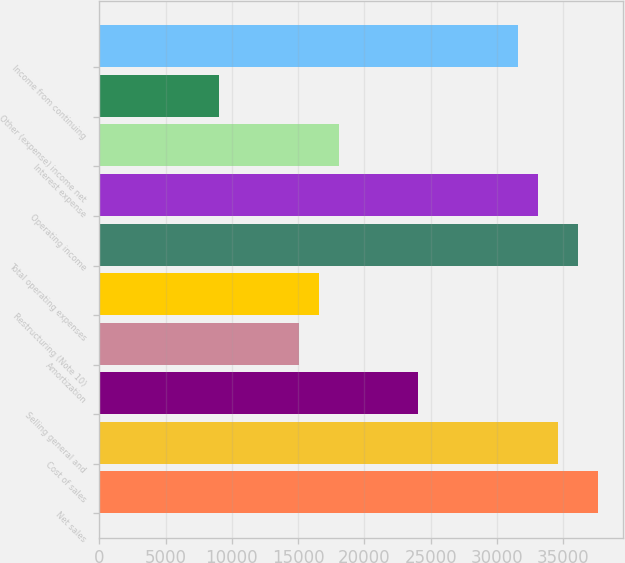Convert chart to OTSL. <chart><loc_0><loc_0><loc_500><loc_500><bar_chart><fcel>Net sales<fcel>Cost of sales<fcel>Selling general and<fcel>Amortization<fcel>Restructuring (Note 10)<fcel>Total operating expenses<fcel>Operating income<fcel>Interest expense<fcel>Other (expense) income net<fcel>Income from continuing<nl><fcel>37627.4<fcel>34617.2<fcel>24081.6<fcel>15051<fcel>16556.1<fcel>36122.3<fcel>33112.1<fcel>18061.2<fcel>9030.68<fcel>31607<nl></chart> 